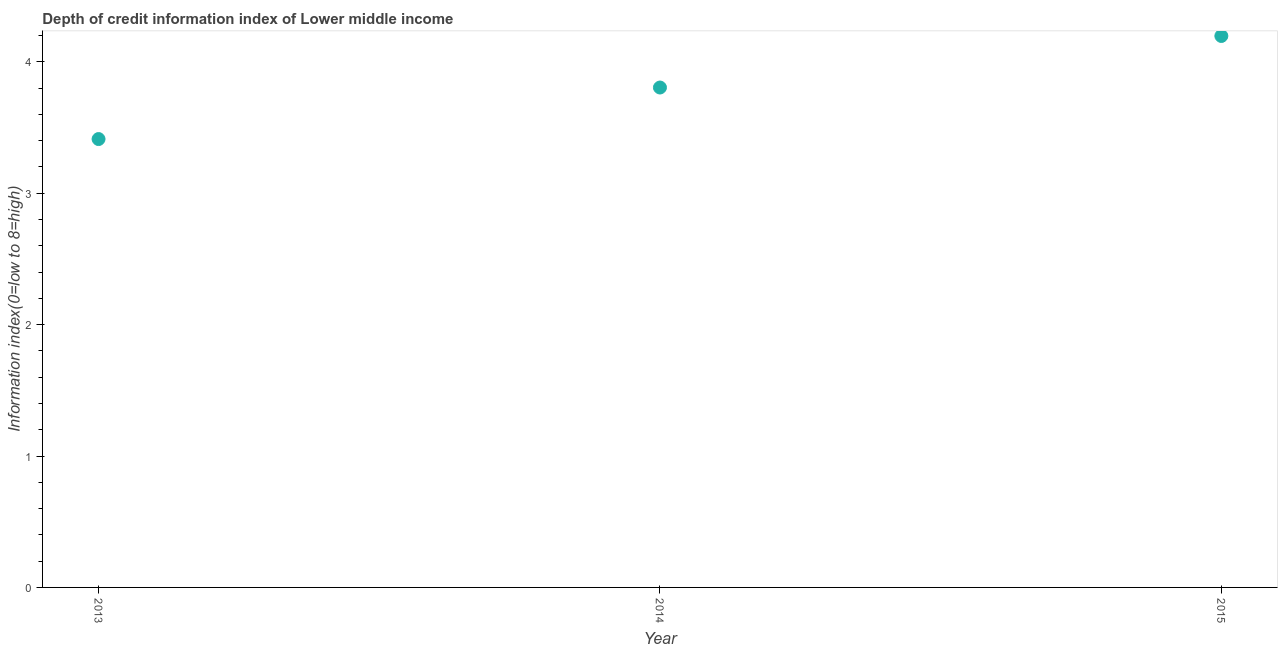What is the depth of credit information index in 2014?
Give a very brief answer. 3.8. Across all years, what is the maximum depth of credit information index?
Provide a succinct answer. 4.2. Across all years, what is the minimum depth of credit information index?
Give a very brief answer. 3.41. In which year was the depth of credit information index maximum?
Offer a terse response. 2015. What is the sum of the depth of credit information index?
Give a very brief answer. 11.41. What is the difference between the depth of credit information index in 2013 and 2014?
Make the answer very short. -0.39. What is the average depth of credit information index per year?
Provide a short and direct response. 3.8. What is the median depth of credit information index?
Your answer should be compact. 3.8. Do a majority of the years between 2015 and 2013 (inclusive) have depth of credit information index greater than 1.6 ?
Your answer should be compact. No. What is the ratio of the depth of credit information index in 2013 to that in 2014?
Provide a succinct answer. 0.9. Is the depth of credit information index in 2013 less than that in 2015?
Offer a terse response. Yes. What is the difference between the highest and the second highest depth of credit information index?
Provide a succinct answer. 0.39. Is the sum of the depth of credit information index in 2013 and 2015 greater than the maximum depth of credit information index across all years?
Ensure brevity in your answer.  Yes. What is the difference between the highest and the lowest depth of credit information index?
Give a very brief answer. 0.78. In how many years, is the depth of credit information index greater than the average depth of credit information index taken over all years?
Provide a short and direct response. 1. Does the depth of credit information index monotonically increase over the years?
Ensure brevity in your answer.  Yes. How many dotlines are there?
Give a very brief answer. 1. How many years are there in the graph?
Offer a terse response. 3. What is the difference between two consecutive major ticks on the Y-axis?
Give a very brief answer. 1. Are the values on the major ticks of Y-axis written in scientific E-notation?
Your answer should be compact. No. Does the graph contain grids?
Give a very brief answer. No. What is the title of the graph?
Keep it short and to the point. Depth of credit information index of Lower middle income. What is the label or title of the Y-axis?
Provide a succinct answer. Information index(0=low to 8=high). What is the Information index(0=low to 8=high) in 2013?
Provide a succinct answer. 3.41. What is the Information index(0=low to 8=high) in 2014?
Your response must be concise. 3.8. What is the Information index(0=low to 8=high) in 2015?
Offer a terse response. 4.2. What is the difference between the Information index(0=low to 8=high) in 2013 and 2014?
Provide a short and direct response. -0.39. What is the difference between the Information index(0=low to 8=high) in 2013 and 2015?
Provide a short and direct response. -0.78. What is the difference between the Information index(0=low to 8=high) in 2014 and 2015?
Ensure brevity in your answer.  -0.39. What is the ratio of the Information index(0=low to 8=high) in 2013 to that in 2014?
Offer a terse response. 0.9. What is the ratio of the Information index(0=low to 8=high) in 2013 to that in 2015?
Ensure brevity in your answer.  0.81. What is the ratio of the Information index(0=low to 8=high) in 2014 to that in 2015?
Your response must be concise. 0.91. 